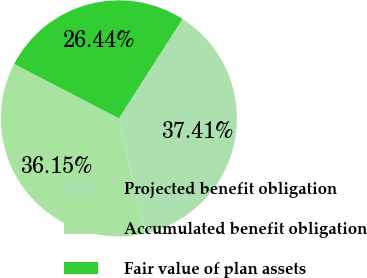Convert chart. <chart><loc_0><loc_0><loc_500><loc_500><pie_chart><fcel>Projected benefit obligation<fcel>Accumulated benefit obligation<fcel>Fair value of plan assets<nl><fcel>37.41%<fcel>36.15%<fcel>26.44%<nl></chart> 